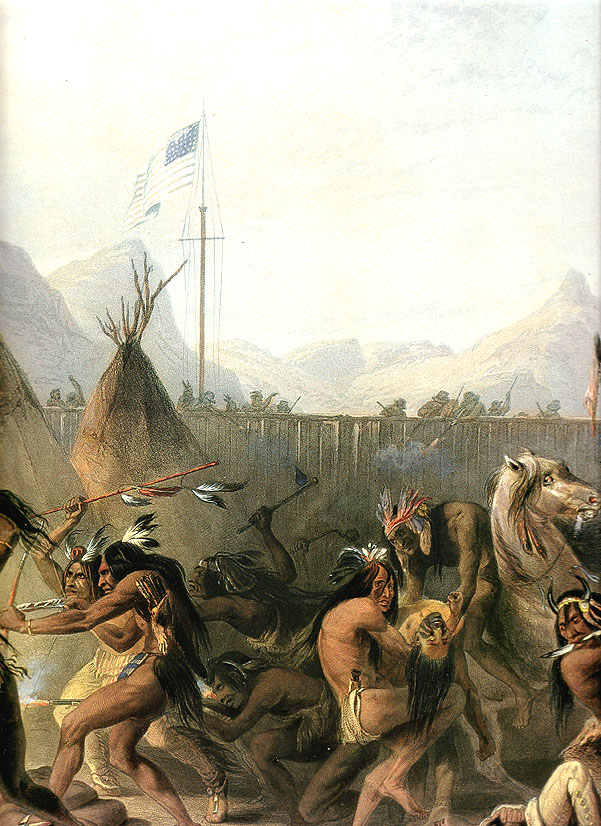What do you think is going on in this snapshot? The image is a historical artwork depicting a group of Native Americans engaged in a dance around an American flag. The painting captures the ceremonial energy of the moment, with participants adorned in traditional clothing and headdresses, moving dynamically in a circular formation. The background features an expansive landscape with mountains and trees, creating a serene and timeless atmosphere. The presence of traditional Native American housing, such as tipis, adds to the authenticity of the scene. An American flag rises prominently on a flagpole, introducing a contrast of cultures within the composition. Rendered in oil on canvas, the artwork's detailed depiction of the clothing, movement, and surrounding environment invites viewers to explore the rich cultural heritage and historical narrative it represents. 